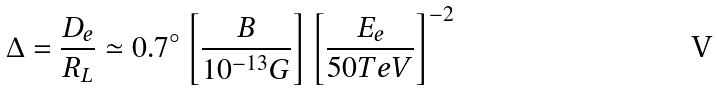Convert formula to latex. <formula><loc_0><loc_0><loc_500><loc_500>\Delta = \frac { D _ { e } } { R _ { L } } \simeq 0 . 7 ^ { \circ } \left [ \frac { B } { 1 0 ^ { - 1 3 } G } \right ] \left [ \frac { E _ { e } } { 5 0 T e V } \right ] ^ { - 2 }</formula> 